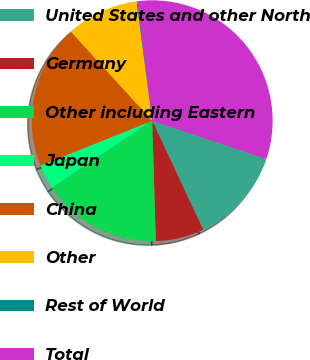Convert chart to OTSL. <chart><loc_0><loc_0><loc_500><loc_500><pie_chart><fcel>United States and other North<fcel>Germany<fcel>Other including Eastern<fcel>Japan<fcel>China<fcel>Other<fcel>Rest of World<fcel>Total<nl><fcel>12.9%<fcel>6.5%<fcel>16.1%<fcel>3.3%<fcel>19.3%<fcel>9.7%<fcel>0.1%<fcel>32.11%<nl></chart> 